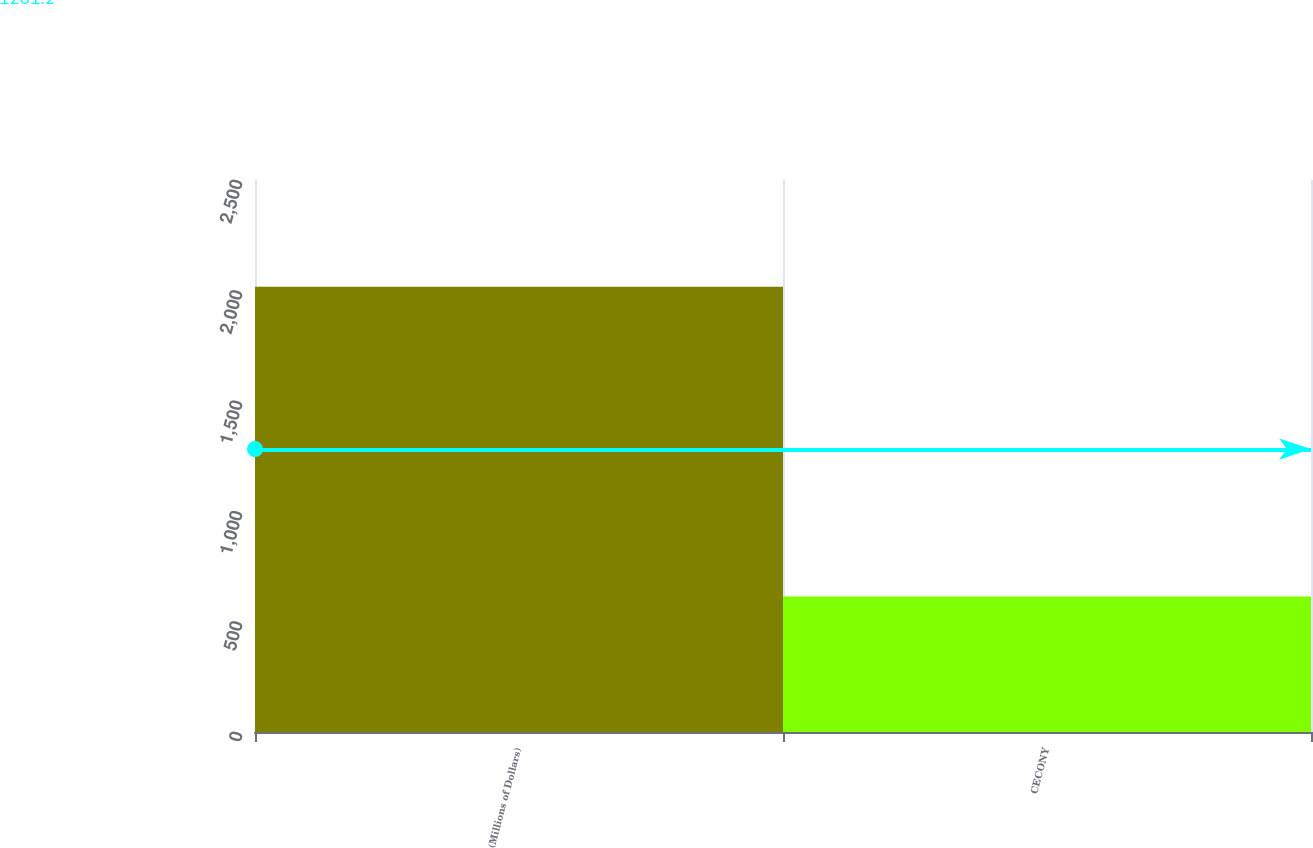Convert chart to OTSL. <chart><loc_0><loc_0><loc_500><loc_500><bar_chart><fcel>(Millions of Dollars)<fcel>CECONY<nl><fcel>2017<fcel>614<nl></chart> 